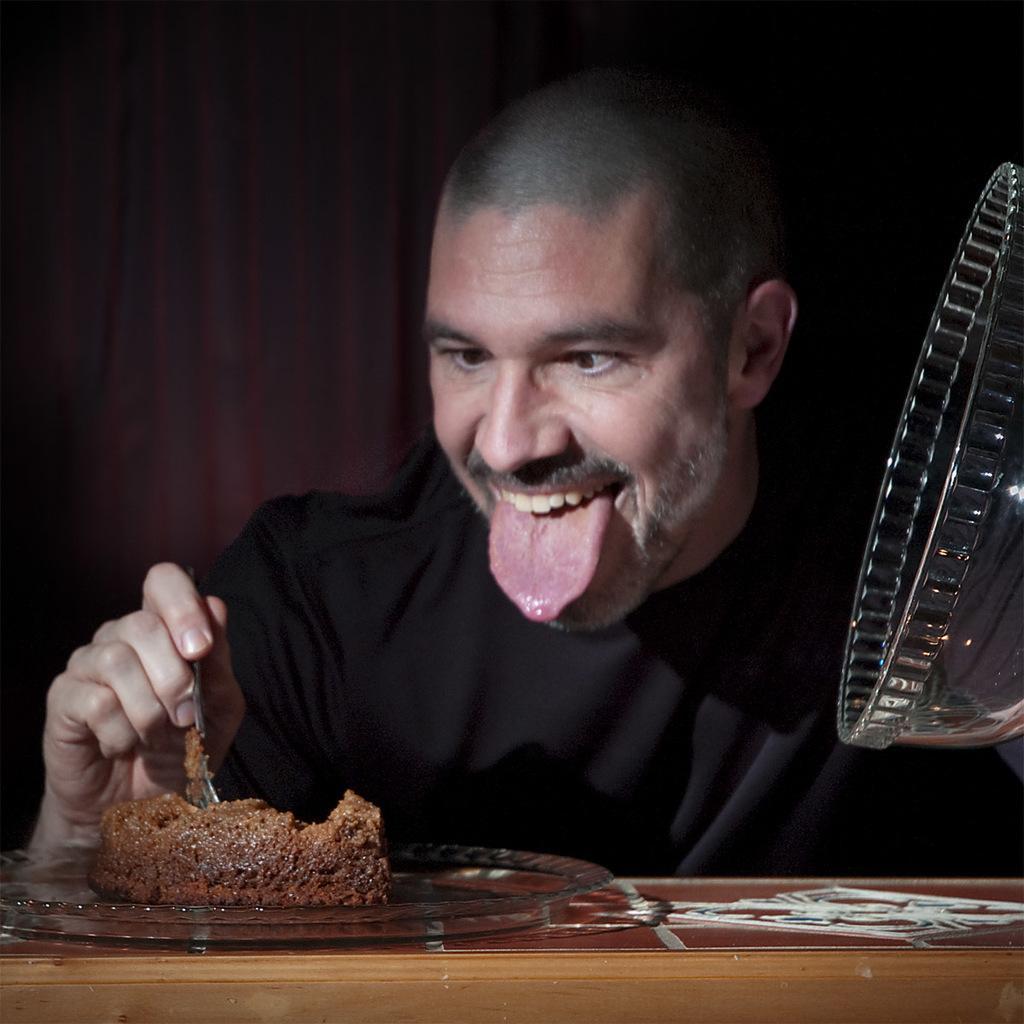Could you give a brief overview of what you see in this image? In this picture we can see a man holding a spoon. In front of the man, there is food in a plate and the plate is on the wooden surface. On the right side of the image, there is an object. Behind the man, there is a dark background. 